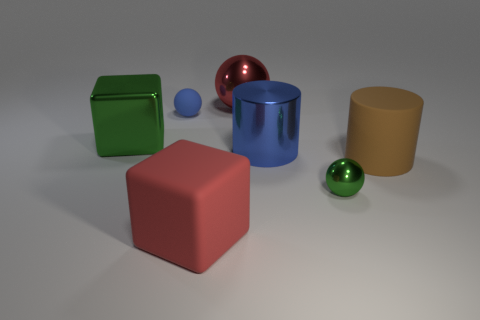Subtract all metallic spheres. How many spheres are left? 1 Add 3 objects. How many objects exist? 10 Subtract all blue balls. How many balls are left? 2 Subtract 1 cubes. How many cubes are left? 1 Add 5 shiny blocks. How many shiny blocks are left? 6 Add 5 metal spheres. How many metal spheres exist? 7 Subtract 1 green balls. How many objects are left? 6 Subtract all spheres. How many objects are left? 4 Subtract all purple cylinders. Subtract all red blocks. How many cylinders are left? 2 Subtract all tiny brown rubber objects. Subtract all green objects. How many objects are left? 5 